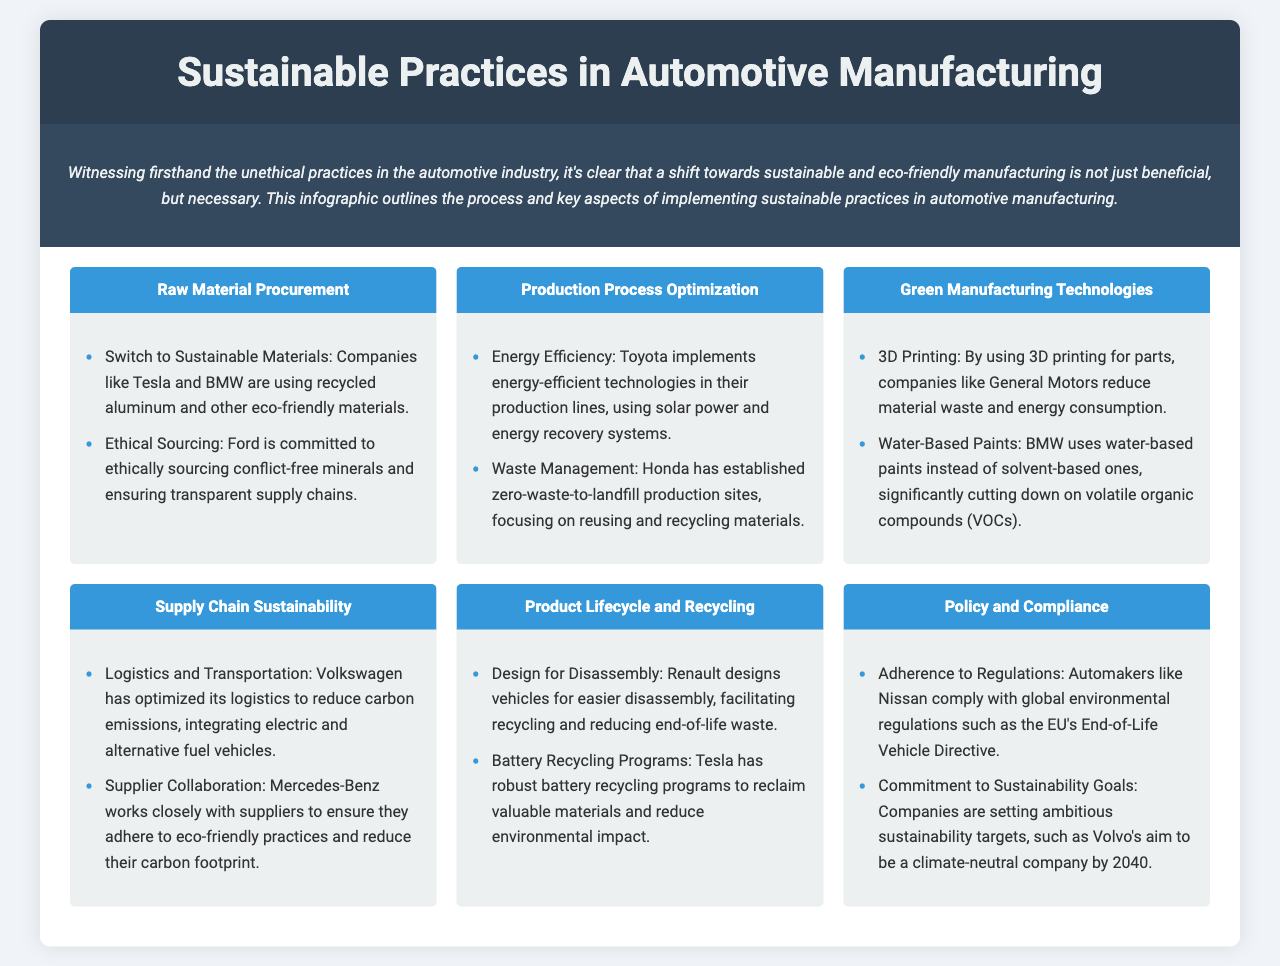What are two materials used in sustainable practices? The document mentions recycled aluminum and eco-friendly materials as examples used by companies in sustainable practices.
Answer: Recycled aluminum, eco-friendly materials Which company focuses on zero-waste-to-landfill production? Honda is specifically mentioned for establishing zero-waste-to-landfill production sites.
Answer: Honda What technology does Toyota implement for energy efficiency? Toyota uses energy-efficient technologies, including solar power and energy recovery systems, in their production lines.
Answer: Energy-efficient technologies Which manufacturing step involves battery recycling programs? The step titled "Product Lifecycle and Recycling" mentions Tesla's robust battery recycling programs.
Answer: Product Lifecycle and Recycling What is a commitment made by Volvo regarding sustainability? The document states that Volvo aims to be a climate-neutral company by 2040.
Answer: Climate-neutral by 2040 What type of paint does BMW use to reduce VOCs? BMW uses water-based paints to significantly cut down on volatile organic compounds.
Answer: Water-based paints Which company utilizes 3D printing for parts? General Motors is the company mentioned that uses 3D printing to reduce material waste and energy consumption.
Answer: General Motors What is the main focus of "Supply Chain Sustainability"? The main focus includes logistics and transportation, and supplier collaboration to ensure eco-friendly practices.
Answer: Logistics and transportation, supplier collaboration 